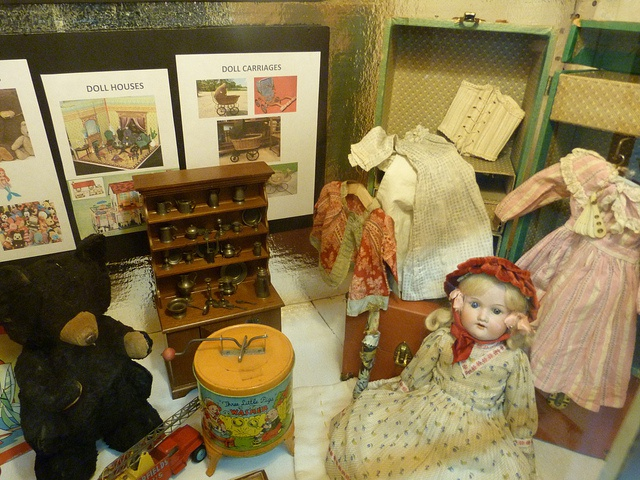Describe the objects in this image and their specific colors. I can see teddy bear in black, olive, and tan tones, bowl in black, maroon, and olive tones, bowl in black and olive tones, bowl in black and olive tones, and cup in black and olive tones in this image. 